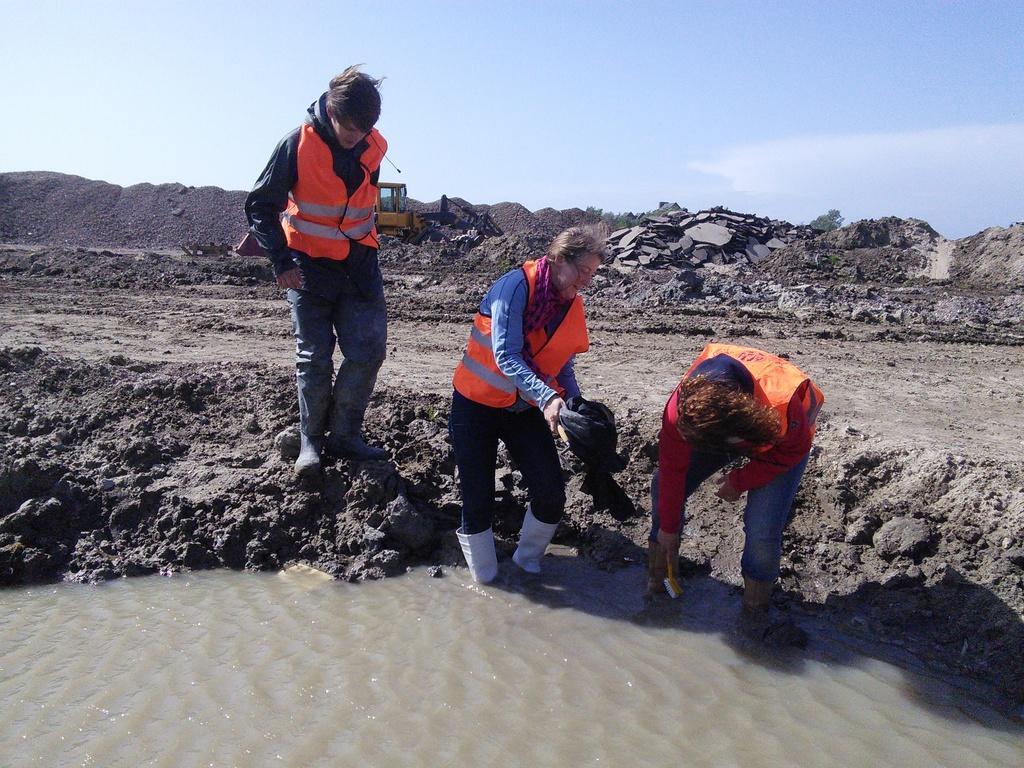Please provide a concise description of this image. In this picture there are two persons standing and holding the objects and there is a person standing. In the foreground there is water. At the back there is mud and there is a vehicle. At the top there is sky and there are clouds. 